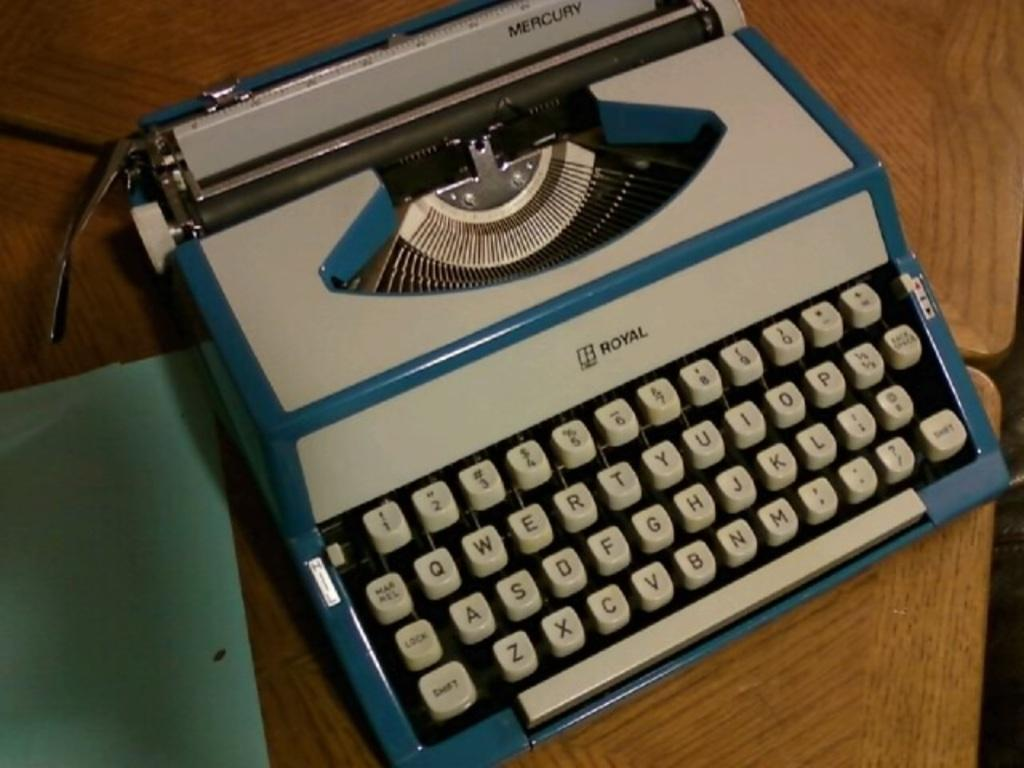<image>
Render a clear and concise summary of the photo. A blue and white model of the royal typewriter. 